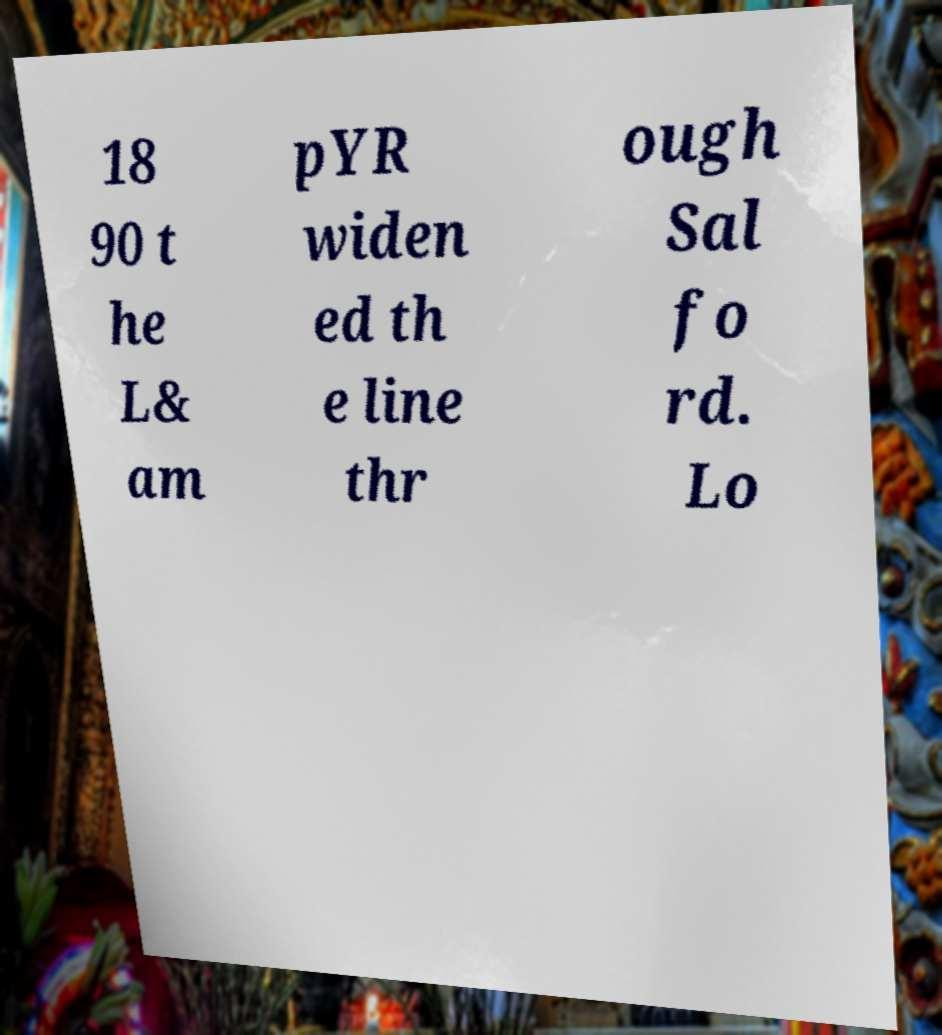Could you extract and type out the text from this image? 18 90 t he L& am pYR widen ed th e line thr ough Sal fo rd. Lo 